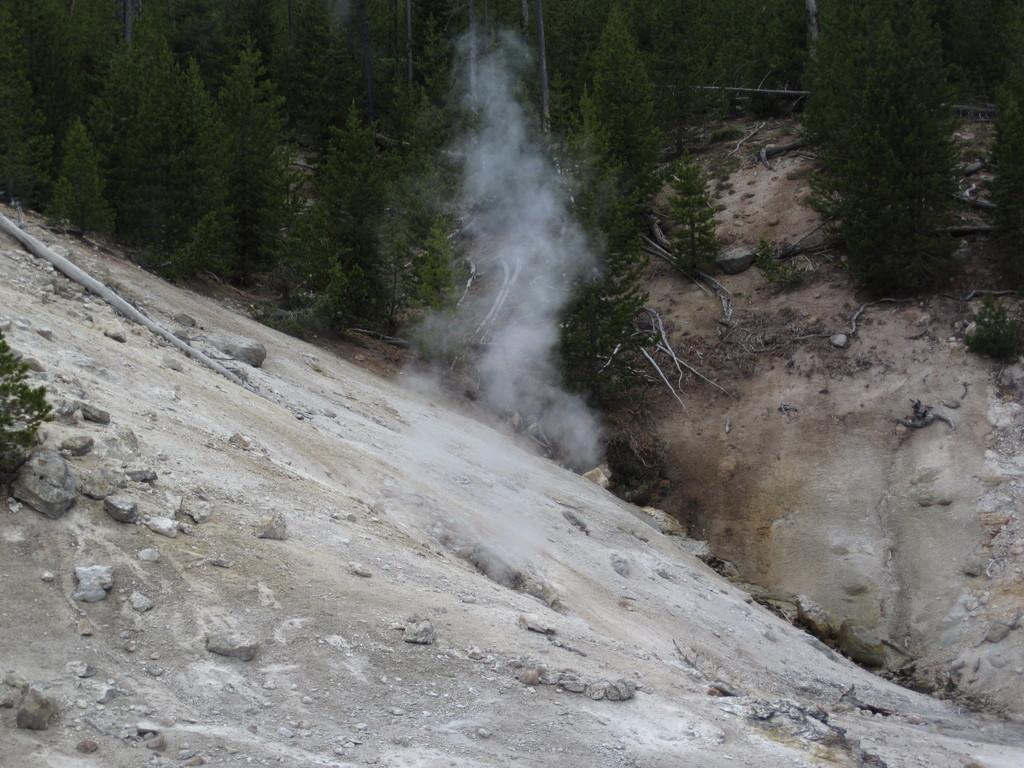In one or two sentences, can you explain what this image depicts? In this picture we can see some trees and hills. 